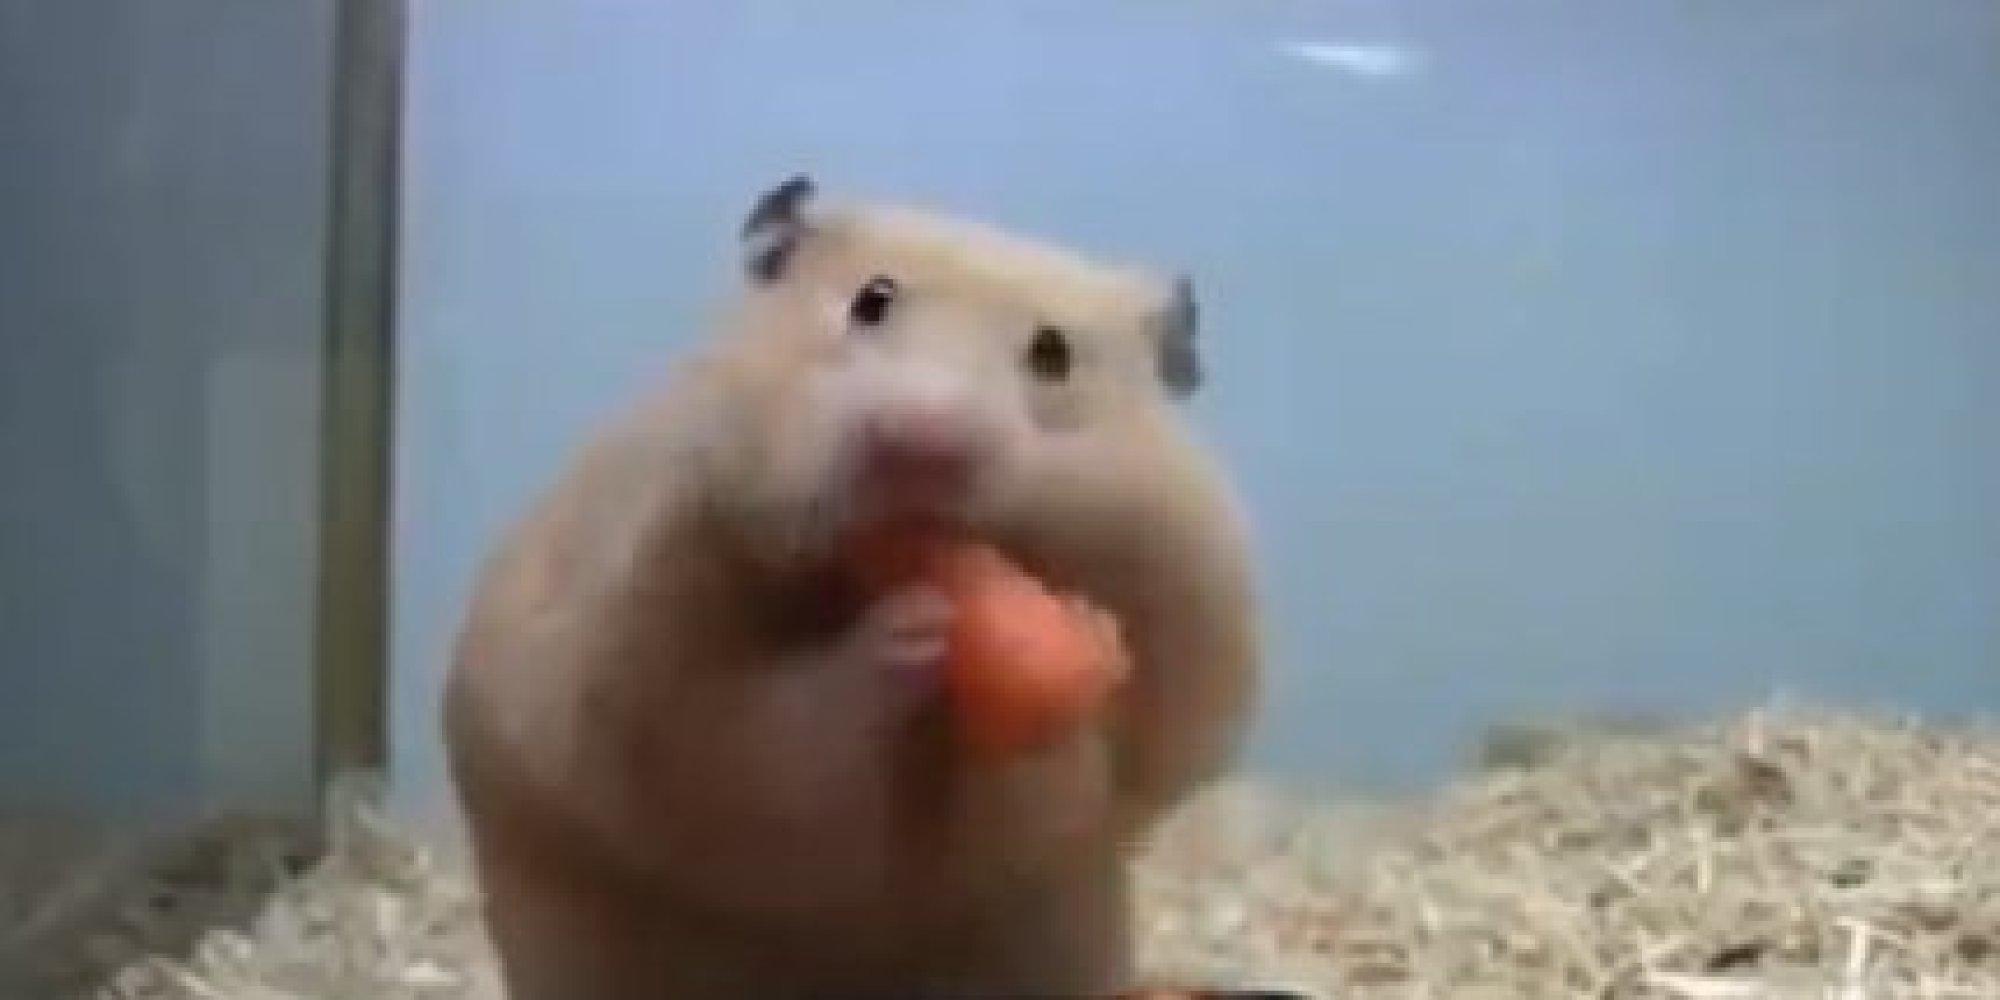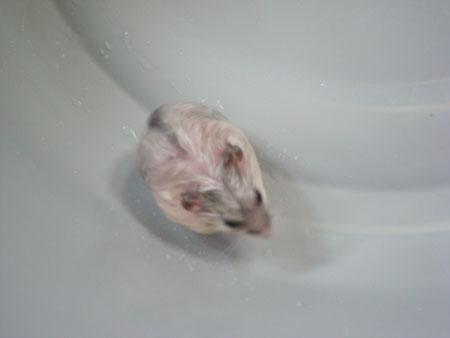The first image is the image on the left, the second image is the image on the right. For the images shown, is this caption "A pet rodent is held in the palm of one hand in one image, and the other image shows a hamster looking mostly forward." true? Answer yes or no. No. The first image is the image on the left, the second image is the image on the right. Analyze the images presented: Is the assertion "The right image contains a human hand holding a rodent." valid? Answer yes or no. No. 